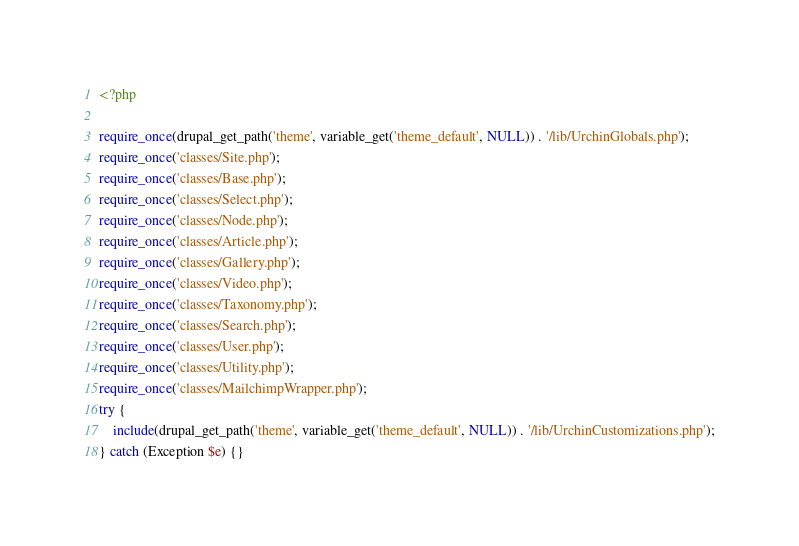Convert code to text. <code><loc_0><loc_0><loc_500><loc_500><_PHP_><?php

require_once(drupal_get_path('theme', variable_get('theme_default', NULL)) . '/lib/UrchinGlobals.php');
require_once('classes/Site.php');
require_once('classes/Base.php');
require_once('classes/Select.php');
require_once('classes/Node.php');
require_once('classes/Article.php');
require_once('classes/Gallery.php');
require_once('classes/Video.php');
require_once('classes/Taxonomy.php');
require_once('classes/Search.php');
require_once('classes/User.php');
require_once('classes/Utility.php');
require_once('classes/MailchimpWrapper.php');
try {
    include(drupal_get_path('theme', variable_get('theme_default', NULL)) . '/lib/UrchinCustomizations.php');
} catch (Exception $e) {}
</code> 